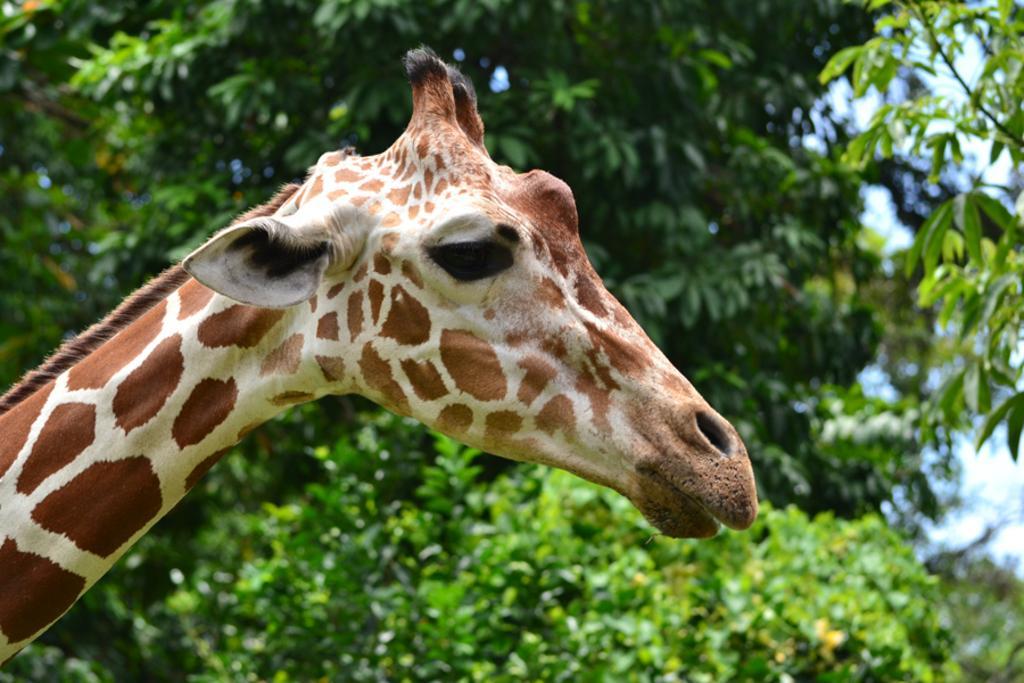Could you give a brief overview of what you see in this image? In this image there is a giraffe. In the background we can see trees. 